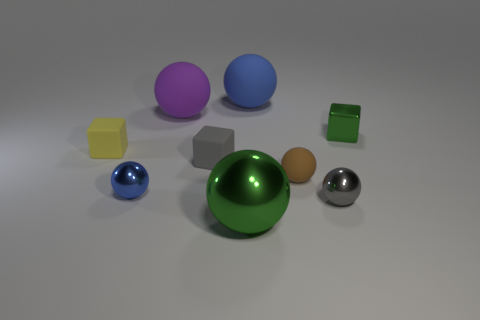What material is the large ball that is the same color as the small shiny cube?
Give a very brief answer. Metal. There is a sphere that is both in front of the blue shiny ball and left of the gray shiny ball; what is its material?
Your answer should be very brief. Metal. How many gray rubber cubes are the same size as the green ball?
Your answer should be very brief. 0. What number of matte things are big blue cylinders or big green balls?
Your answer should be very brief. 0. What material is the big green sphere?
Your response must be concise. Metal. What number of gray things are to the right of the gray rubber thing?
Make the answer very short. 1. Is the material of the green thing behind the gray block the same as the big green object?
Keep it short and to the point. Yes. What number of purple objects are the same shape as the small gray metal object?
Offer a very short reply. 1. What number of tiny things are either blue metallic cylinders or gray cubes?
Your answer should be very brief. 1. Do the big thing that is in front of the tiny green metallic object and the small shiny block have the same color?
Your response must be concise. Yes. 